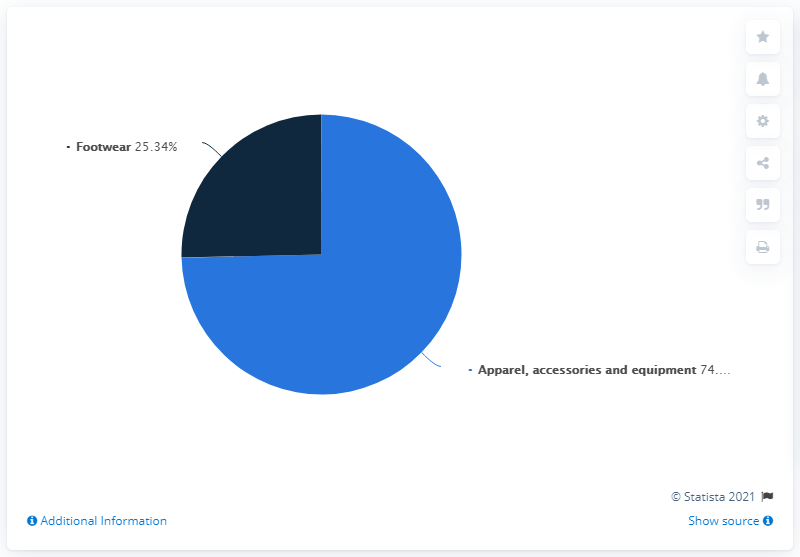Identify some key points in this picture. In 2020, the percentage share of Columbia Sportswear Company's worldwide revenue was divided among three categories: Apparel Accessories, Equipment, and Footwear. The category with the highest percentage share was Apparel Accessories, accounting for 49.32% of the company's global revenue. In 2020, the highest selling category of Columbia Sportswear Company worldwide was apparel, accessories, and equipment. 